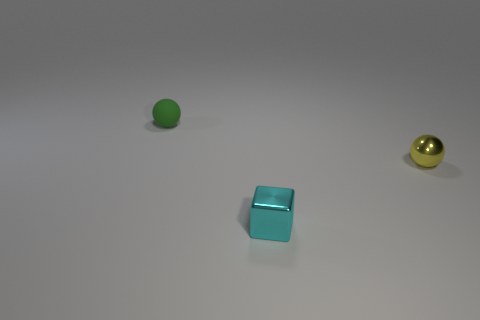Add 1 green matte spheres. How many objects exist? 4 Subtract all cubes. How many objects are left? 2 Subtract all small blue things. Subtract all cyan cubes. How many objects are left? 2 Add 1 tiny matte spheres. How many tiny matte spheres are left? 2 Add 2 small cyan metallic things. How many small cyan metallic things exist? 3 Subtract 1 green balls. How many objects are left? 2 